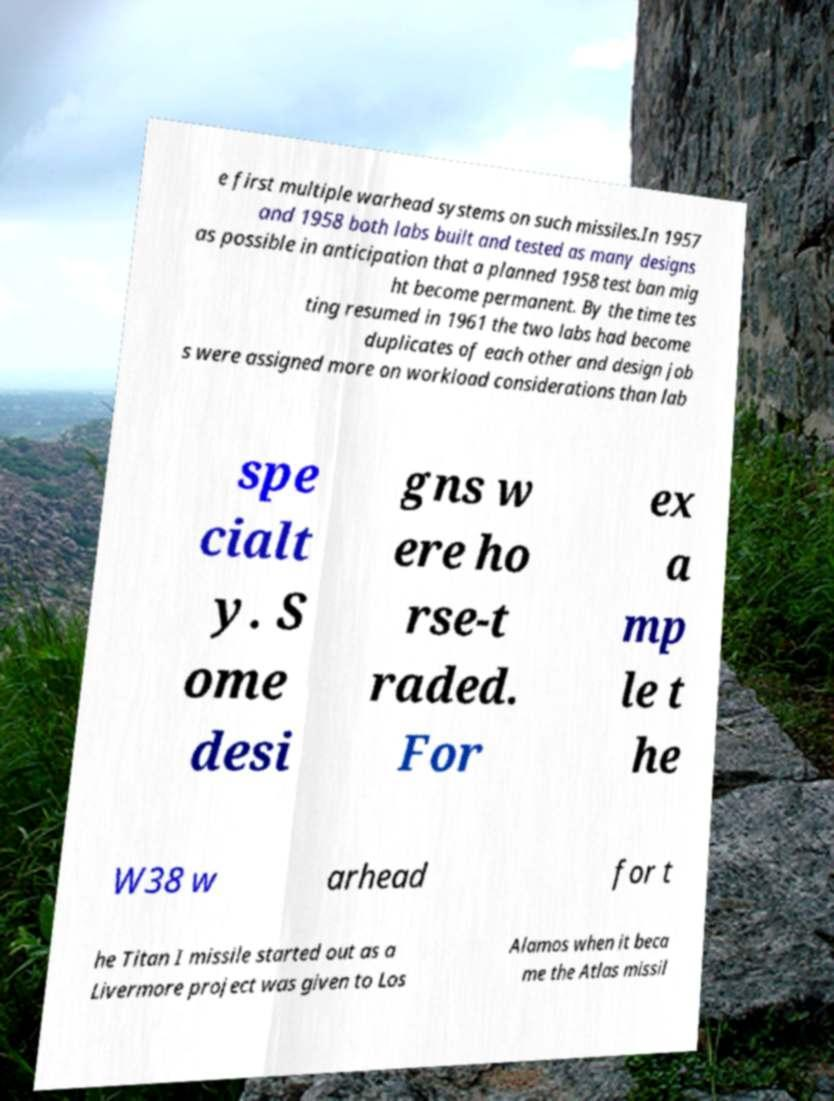What messages or text are displayed in this image? I need them in a readable, typed format. e first multiple warhead systems on such missiles.In 1957 and 1958 both labs built and tested as many designs as possible in anticipation that a planned 1958 test ban mig ht become permanent. By the time tes ting resumed in 1961 the two labs had become duplicates of each other and design job s were assigned more on workload considerations than lab spe cialt y. S ome desi gns w ere ho rse-t raded. For ex a mp le t he W38 w arhead for t he Titan I missile started out as a Livermore project was given to Los Alamos when it beca me the Atlas missil 